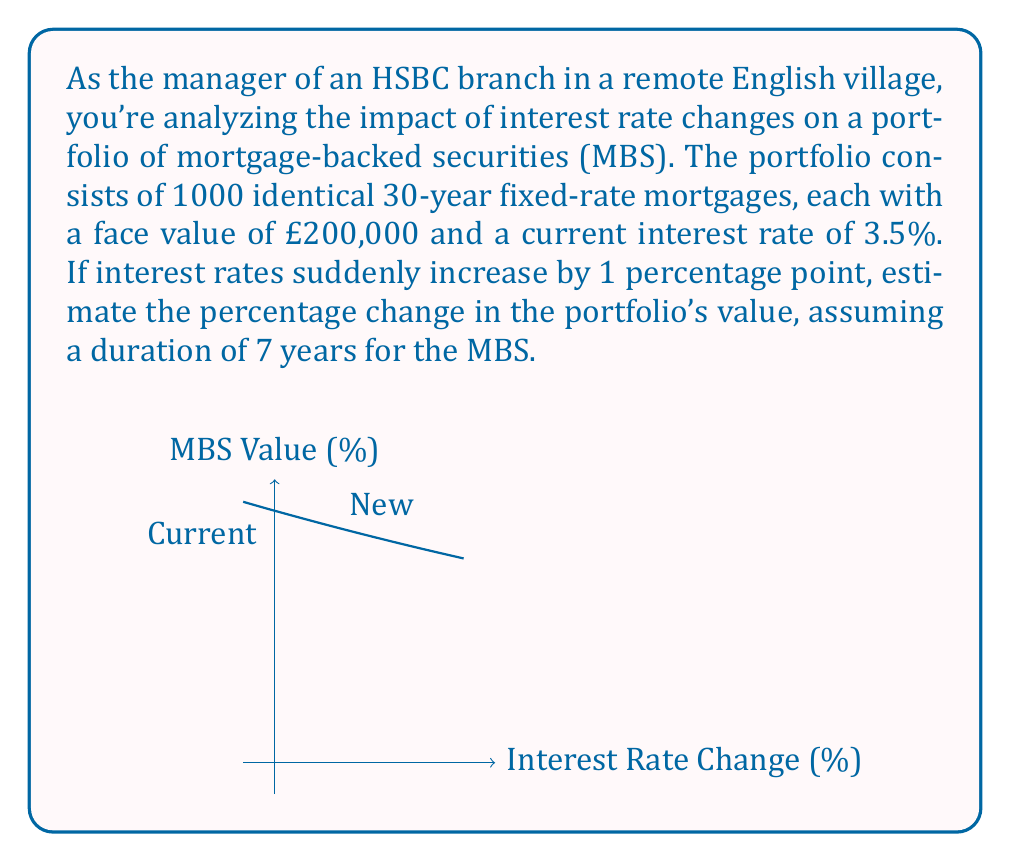Can you answer this question? To solve this problem, we'll use the concept of duration to estimate the change in the value of mortgage-backed securities due to interest rate changes. The steps are as follows:

1) The formula for estimating the percentage change in bond price (or MBS value) is:

   $$\text{Percentage Change} \approx -\text{Duration} \times \text{Change in Interest Rate}$$

2) We're given:
   - Duration (D) = 7 years
   - Change in Interest Rate (Δr) = +1% = 0.01

3) Plugging these values into the formula:

   $$\text{Percentage Change} \approx -7 \times 0.01 = -0.07 = -7\%$$

4) This means the value of the MBS portfolio is expected to decrease by approximately 7%.

5) To calculate the new value of the portfolio:
   - Current portfolio value = 1000 × £200,000 = £200,000,000
   - New portfolio value ≈ £200,000,000 × (1 - 0.07) = £186,000,000

6) The change in portfolio value:
   $$£200,000,000 - £186,000,000 = £14,000,000$$

This calculation demonstrates the inverse relationship between interest rates and MBS values, which is crucial for managing interest rate risk in a bank's portfolio.
Answer: -7% 